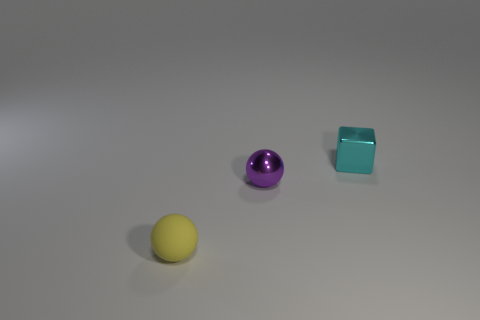Add 2 purple things. How many objects exist? 5 Subtract all purple balls. How many balls are left? 1 Subtract all cubes. How many objects are left? 2 Subtract all cyan blocks. How many purple spheres are left? 1 Subtract 1 yellow spheres. How many objects are left? 2 Subtract 2 spheres. How many spheres are left? 0 Subtract all red blocks. Subtract all brown cylinders. How many blocks are left? 1 Subtract all small cyan cubes. Subtract all small purple metallic spheres. How many objects are left? 1 Add 3 yellow rubber balls. How many yellow rubber balls are left? 4 Add 3 cyan objects. How many cyan objects exist? 4 